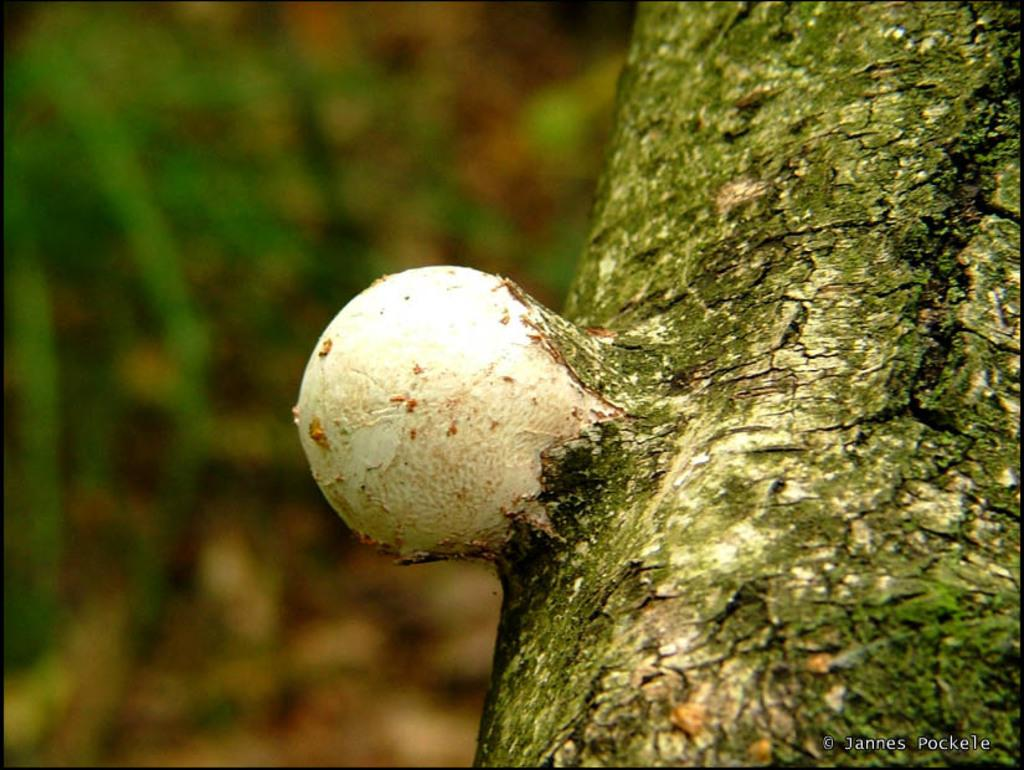What can be seen on the right side of the image? There is a tree trunk on the right side of the image. Can you describe the object in the image? Unfortunately, the provided facts do not give any information about the object in the image. What is the condition of the left side of the image? The left side of the image is blurred. How many sisters are present in the image? There is no mention of sisters in the provided facts, so we cannot determine if any are present in the image. What type of chicken or hen can be seen in the image? There is no chicken or hen present in the image. 